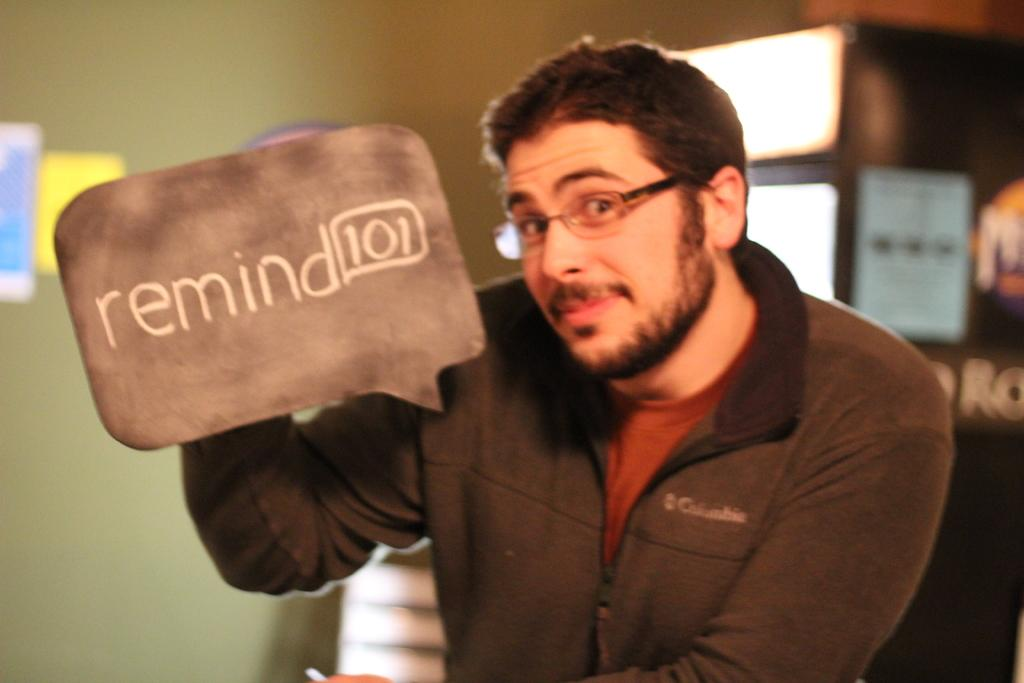What is the main subject of the picture? The main subject of the picture is a man. Can you describe the man's attire? The man is wearing spectacles, a jacket, and a t-shirt. What is the man holding in the picture? The man is holding a board. What can be seen in the background of the picture? There are lights, posters, and other objects visible on the wall in the background. How many snails can be seen crawling on the man's trousers in the image? There are no snails present in the image, and the man is not wearing trousers; he is wearing a jacket and a t-shirt. 